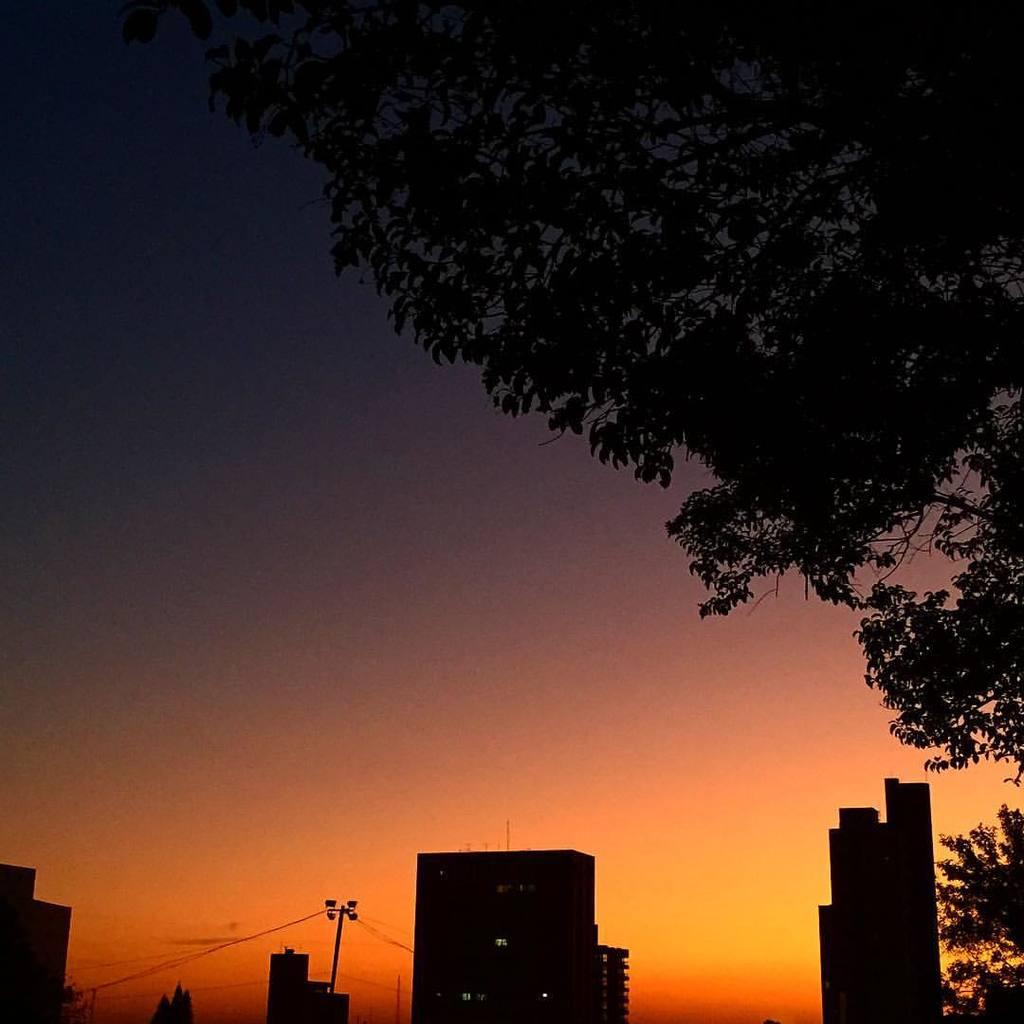What type of structures are present in the image? There is a group of buildings in the image. What else can be seen in the image besides the buildings? There are poles in the image. What is visible in the background of the image? There are trees and the sky visible in the background of the image. What type of maid can be seen working in the image? There is no maid present in the image. What is the hope of the trees in the background of the image? The trees in the background of the image do not have hopes, as they are inanimate objects. 